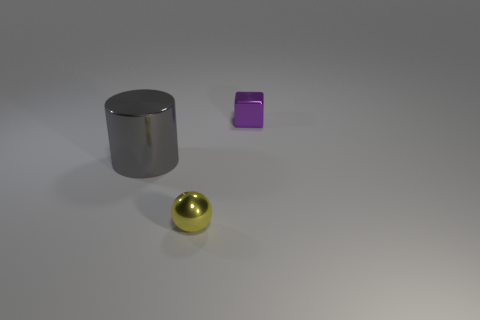Add 1 tiny gray metal things. How many objects exist? 4 Add 2 tiny purple rubber cylinders. How many tiny purple rubber cylinders exist? 2 Subtract 0 yellow cubes. How many objects are left? 3 Subtract all cubes. How many objects are left? 2 Subtract all big cylinders. Subtract all gray matte objects. How many objects are left? 2 Add 3 yellow metallic spheres. How many yellow metallic spheres are left? 4 